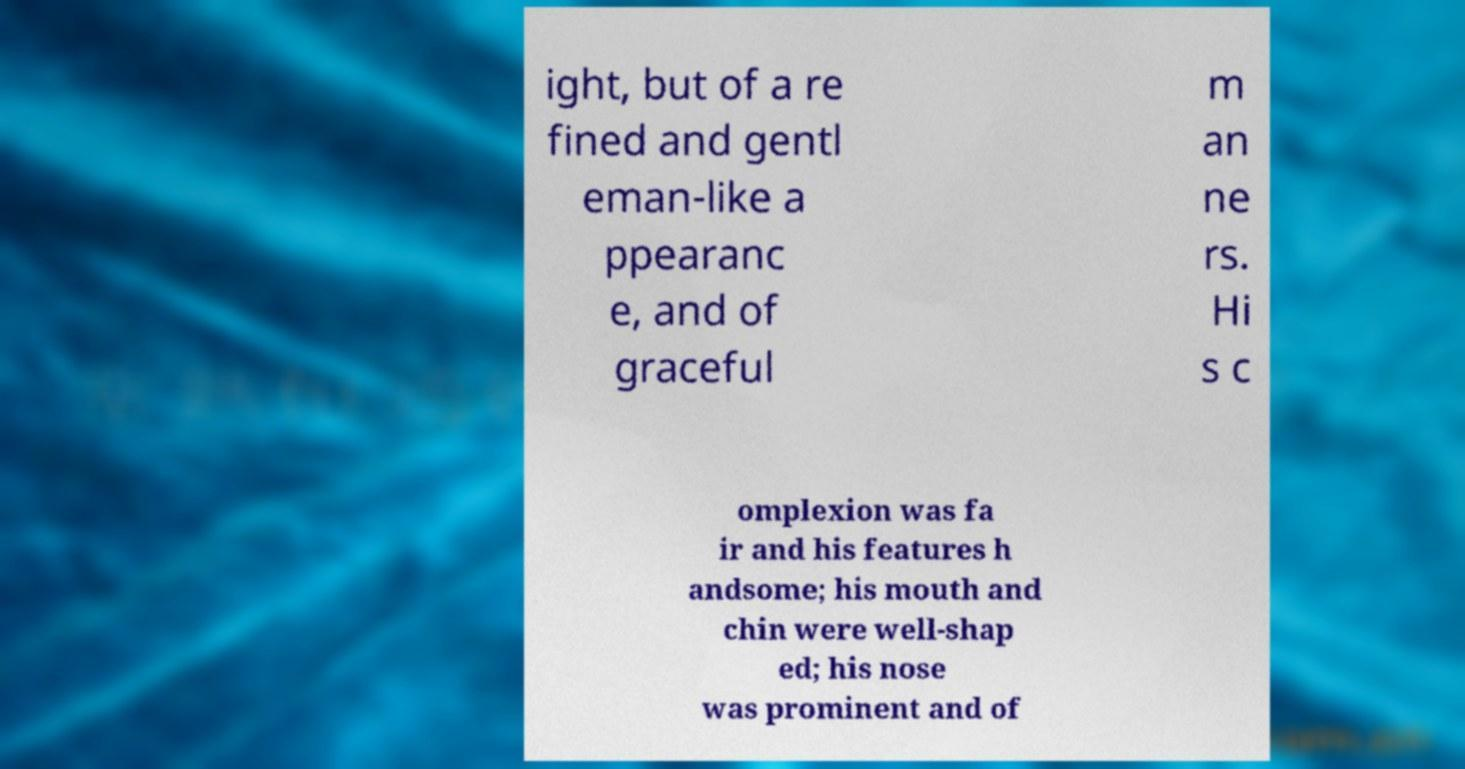There's text embedded in this image that I need extracted. Can you transcribe it verbatim? ight, but of a re fined and gentl eman-like a ppearanc e, and of graceful m an ne rs. Hi s c omplexion was fa ir and his features h andsome; his mouth and chin were well-shap ed; his nose was prominent and of 